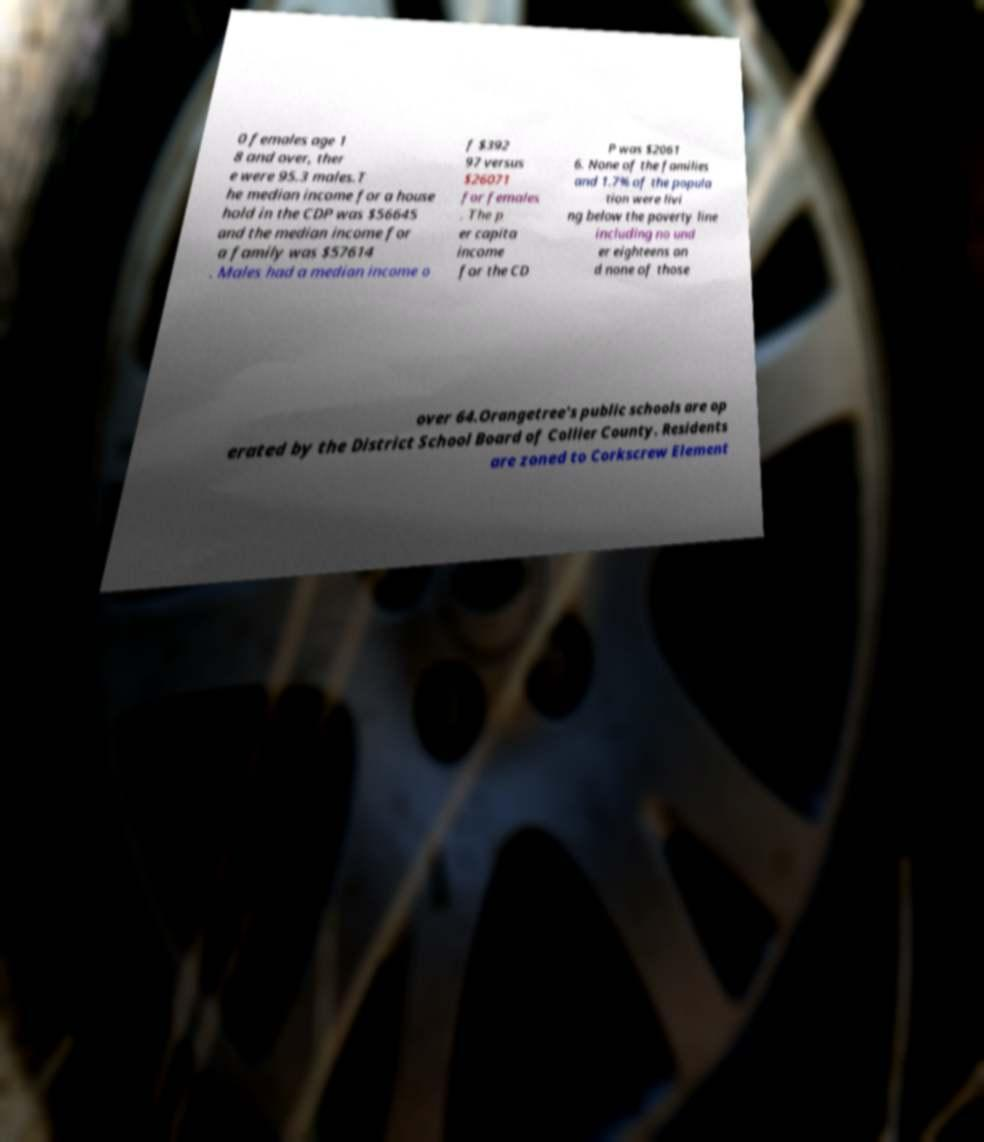Can you accurately transcribe the text from the provided image for me? 0 females age 1 8 and over, ther e were 95.3 males.T he median income for a house hold in the CDP was $56645 and the median income for a family was $57614 . Males had a median income o f $392 97 versus $26071 for females . The p er capita income for the CD P was $2061 6. None of the families and 1.7% of the popula tion were livi ng below the poverty line including no und er eighteens an d none of those over 64.Orangetree's public schools are op erated by the District School Board of Collier County. Residents are zoned to Corkscrew Element 